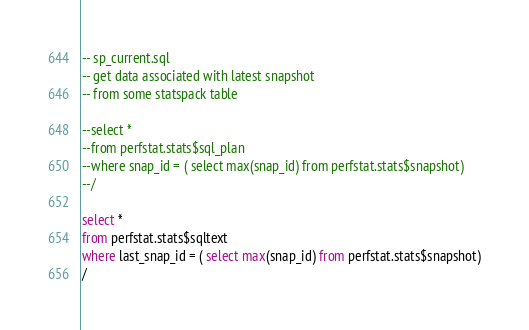<code> <loc_0><loc_0><loc_500><loc_500><_SQL_>
-- sp_current.sql
-- get data associated with latest snapshot
-- from some statspack table

--select * 
--from perfstat.stats$sql_plan
--where snap_id = ( select max(snap_id) from perfstat.stats$snapshot)
--/

select * 
from perfstat.stats$sqltext
where last_snap_id = ( select max(snap_id) from perfstat.stats$snapshot)
/
</code> 